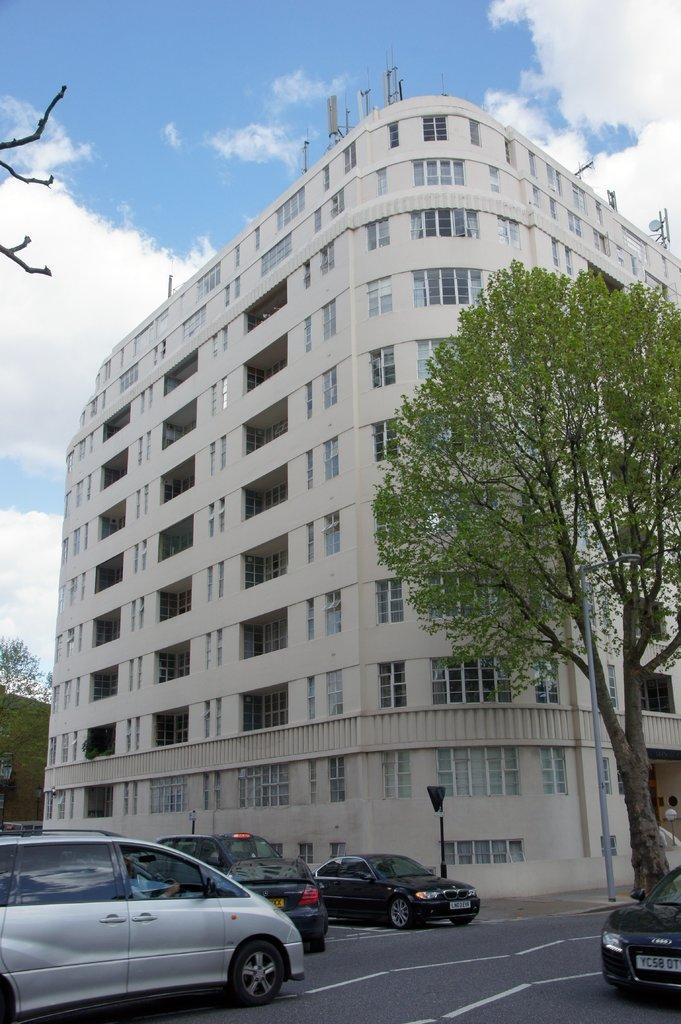What type of vehicles can be seen on the road in the image? There are cars on the road in the image. What structures are present in the image besides the cars? There are poles and a tree on the right side of the image. What can be seen in the background of the image? There is a building in the background of the image. What is visible at the top of the image? The sky is visible at the top of the image. What is the chance of winning the lottery in the image? There is no information about the lottery or winning chances in the image. 